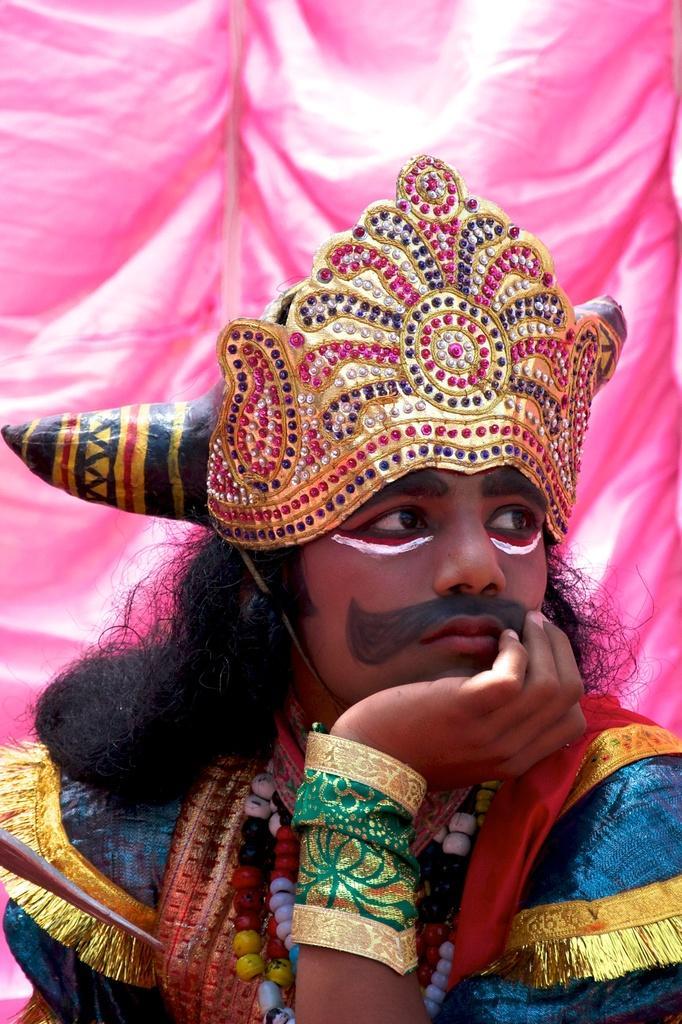How would you summarize this image in a sentence or two? There is a person wearing crown and some pearl chains. On the hand there is a cloth. On the face it is painted. In the background there is a pink curtain. 